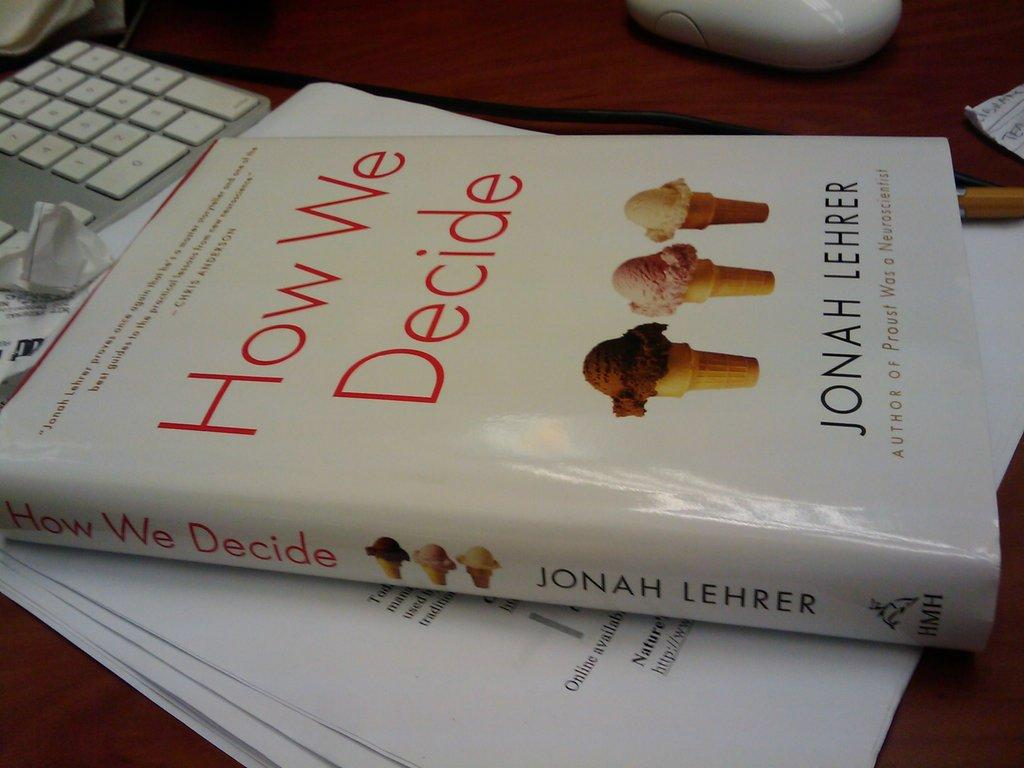<image>
Share a concise interpretation of the image provided. A book titled How We Decide has ice cream cones on the cover. 